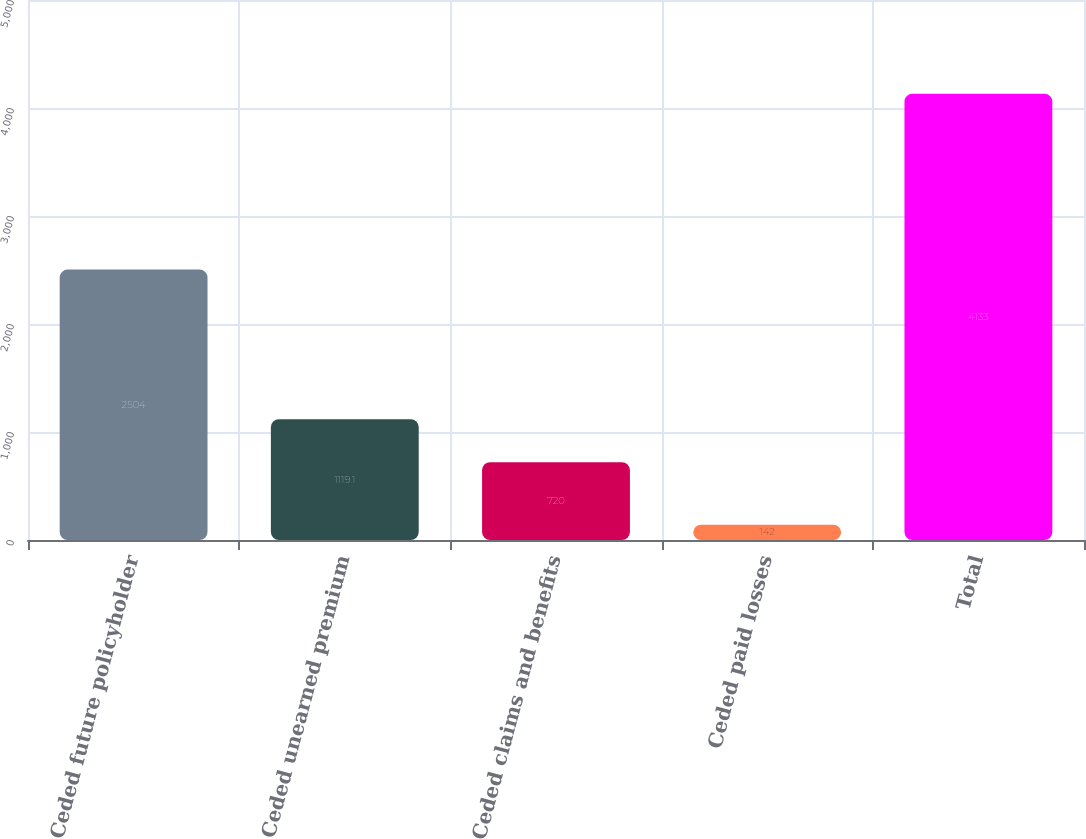Convert chart to OTSL. <chart><loc_0><loc_0><loc_500><loc_500><bar_chart><fcel>Ceded future policyholder<fcel>Ceded unearned premium<fcel>Ceded claims and benefits<fcel>Ceded paid losses<fcel>Total<nl><fcel>2504<fcel>1119.1<fcel>720<fcel>142<fcel>4133<nl></chart> 